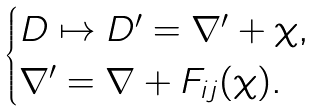Convert formula to latex. <formula><loc_0><loc_0><loc_500><loc_500>\begin{cases} D \mapsto D ^ { \prime } = \nabla ^ { \prime } + \chi , \\ \nabla ^ { \prime } = \nabla + F _ { i j } ( \chi ) . \end{cases}</formula> 